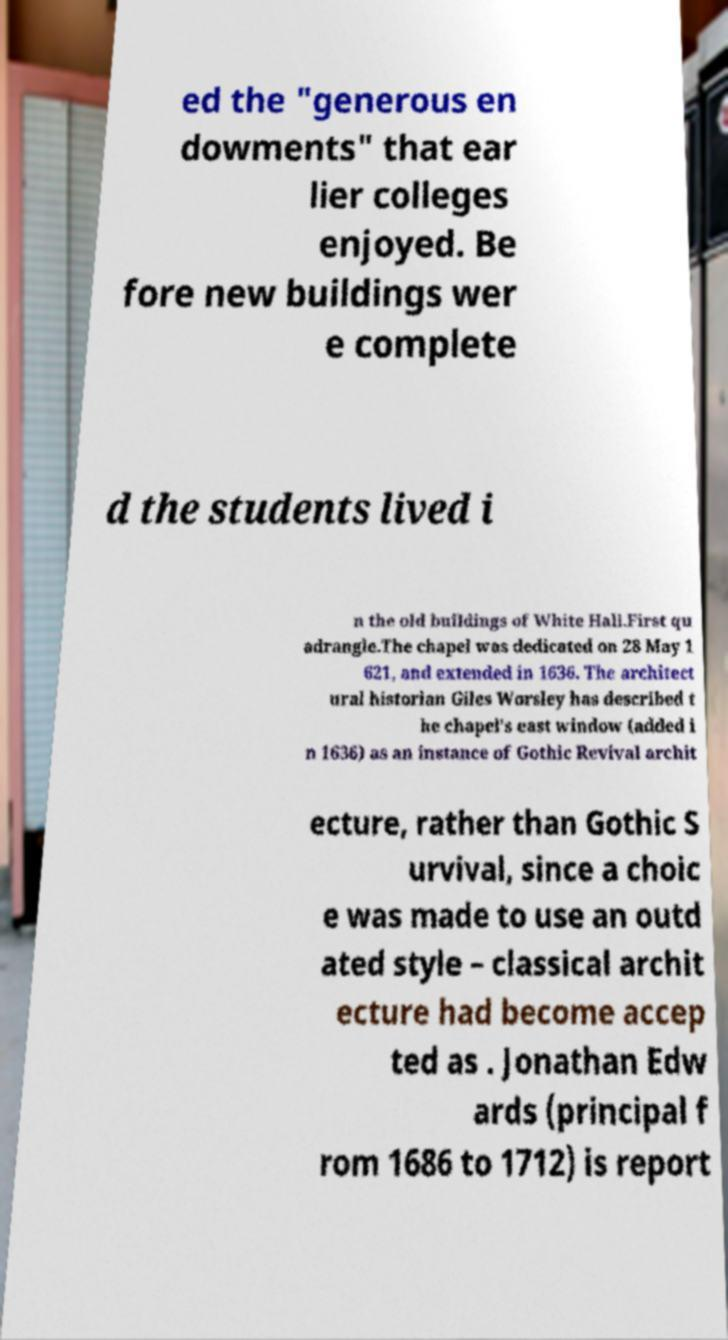Can you accurately transcribe the text from the provided image for me? ed the "generous en dowments" that ear lier colleges enjoyed. Be fore new buildings wer e complete d the students lived i n the old buildings of White Hall.First qu adrangle.The chapel was dedicated on 28 May 1 621, and extended in 1636. The architect ural historian Giles Worsley has described t he chapel's east window (added i n 1636) as an instance of Gothic Revival archit ecture, rather than Gothic S urvival, since a choic e was made to use an outd ated style – classical archit ecture had become accep ted as . Jonathan Edw ards (principal f rom 1686 to 1712) is report 